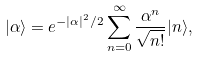Convert formula to latex. <formula><loc_0><loc_0><loc_500><loc_500>| \alpha \rangle = e ^ { - | \alpha | ^ { 2 } / 2 } \sum _ { n = 0 } ^ { \infty } \frac { \alpha ^ { n } } { \sqrt { n ! } } | n \rangle ,</formula> 